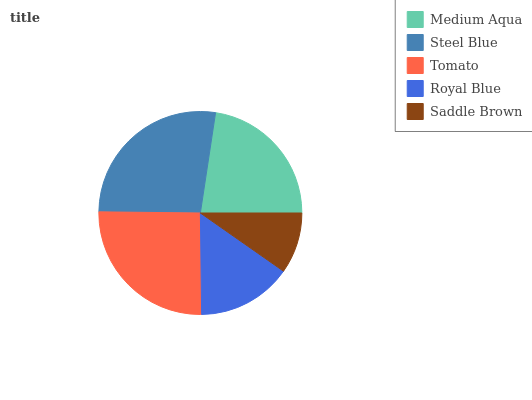Is Saddle Brown the minimum?
Answer yes or no. Yes. Is Steel Blue the maximum?
Answer yes or no. Yes. Is Tomato the minimum?
Answer yes or no. No. Is Tomato the maximum?
Answer yes or no. No. Is Steel Blue greater than Tomato?
Answer yes or no. Yes. Is Tomato less than Steel Blue?
Answer yes or no. Yes. Is Tomato greater than Steel Blue?
Answer yes or no. No. Is Steel Blue less than Tomato?
Answer yes or no. No. Is Medium Aqua the high median?
Answer yes or no. Yes. Is Medium Aqua the low median?
Answer yes or no. Yes. Is Steel Blue the high median?
Answer yes or no. No. Is Tomato the low median?
Answer yes or no. No. 